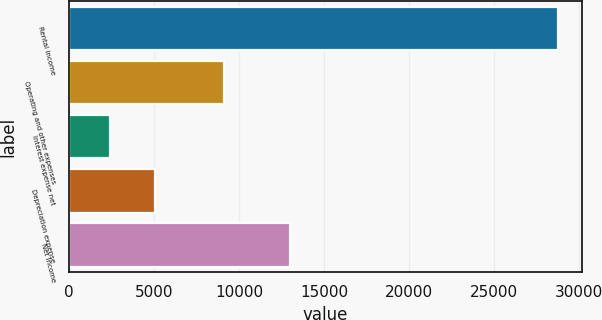<chart> <loc_0><loc_0><loc_500><loc_500><bar_chart><fcel>Rental income<fcel>Operating and other expenses<fcel>Interest expense net<fcel>Depreciation expense<fcel>Net income<nl><fcel>28746<fcel>9098<fcel>2402<fcel>5036.4<fcel>12993<nl></chart> 